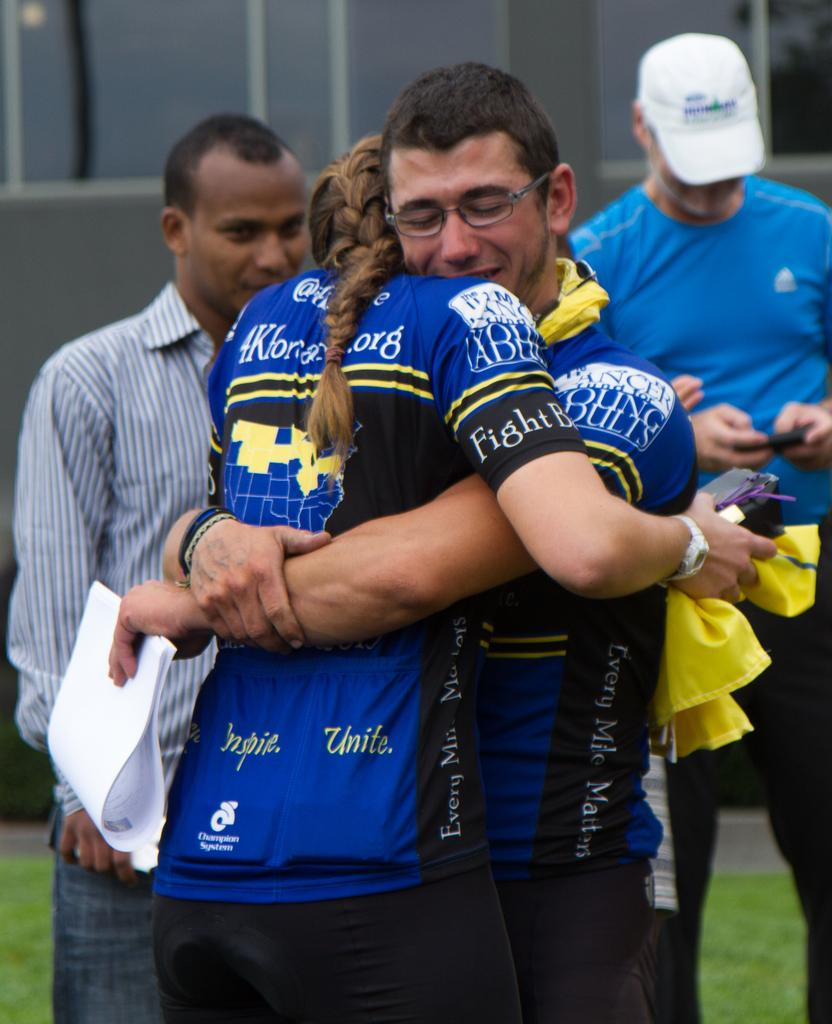<image>
Relay a brief, clear account of the picture shown. A woman in a jersey 4K for something org being hugged by another participant. 